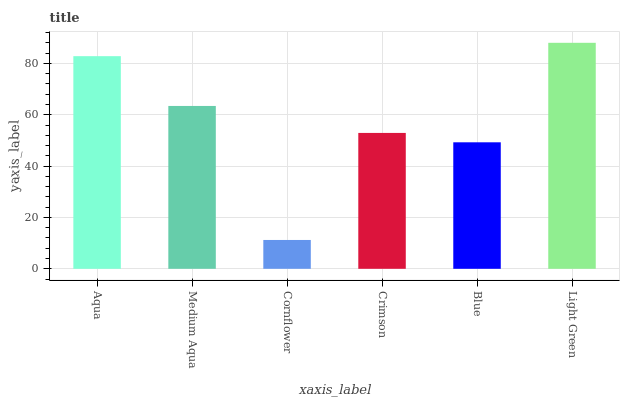Is Cornflower the minimum?
Answer yes or no. Yes. Is Light Green the maximum?
Answer yes or no. Yes. Is Medium Aqua the minimum?
Answer yes or no. No. Is Medium Aqua the maximum?
Answer yes or no. No. Is Aqua greater than Medium Aqua?
Answer yes or no. Yes. Is Medium Aqua less than Aqua?
Answer yes or no. Yes. Is Medium Aqua greater than Aqua?
Answer yes or no. No. Is Aqua less than Medium Aqua?
Answer yes or no. No. Is Medium Aqua the high median?
Answer yes or no. Yes. Is Crimson the low median?
Answer yes or no. Yes. Is Cornflower the high median?
Answer yes or no. No. Is Blue the low median?
Answer yes or no. No. 